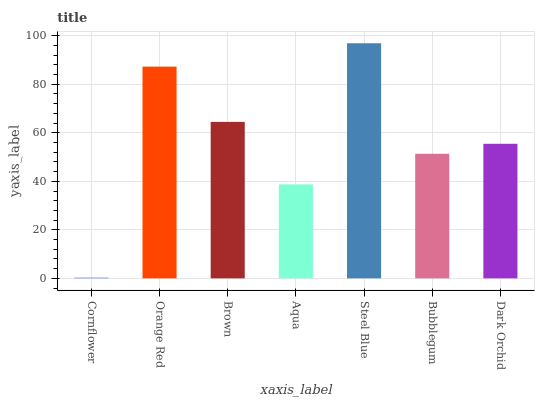Is Cornflower the minimum?
Answer yes or no. Yes. Is Steel Blue the maximum?
Answer yes or no. Yes. Is Orange Red the minimum?
Answer yes or no. No. Is Orange Red the maximum?
Answer yes or no. No. Is Orange Red greater than Cornflower?
Answer yes or no. Yes. Is Cornflower less than Orange Red?
Answer yes or no. Yes. Is Cornflower greater than Orange Red?
Answer yes or no. No. Is Orange Red less than Cornflower?
Answer yes or no. No. Is Dark Orchid the high median?
Answer yes or no. Yes. Is Dark Orchid the low median?
Answer yes or no. Yes. Is Bubblegum the high median?
Answer yes or no. No. Is Brown the low median?
Answer yes or no. No. 